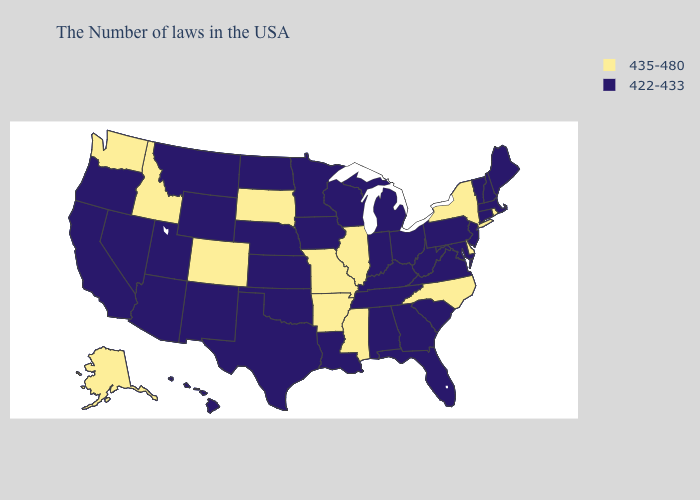Does the first symbol in the legend represent the smallest category?
Short answer required. No. Does Indiana have the same value as Washington?
Short answer required. No. Among the states that border Nebraska , does Colorado have the highest value?
Answer briefly. Yes. What is the lowest value in the MidWest?
Quick response, please. 422-433. Among the states that border Massachusetts , which have the highest value?
Short answer required. Rhode Island, New York. Name the states that have a value in the range 422-433?
Short answer required. Maine, Massachusetts, New Hampshire, Vermont, Connecticut, New Jersey, Maryland, Pennsylvania, Virginia, South Carolina, West Virginia, Ohio, Florida, Georgia, Michigan, Kentucky, Indiana, Alabama, Tennessee, Wisconsin, Louisiana, Minnesota, Iowa, Kansas, Nebraska, Oklahoma, Texas, North Dakota, Wyoming, New Mexico, Utah, Montana, Arizona, Nevada, California, Oregon, Hawaii. Among the states that border Pennsylvania , does Delaware have the lowest value?
Short answer required. No. What is the lowest value in the Northeast?
Give a very brief answer. 422-433. What is the value of Maryland?
Short answer required. 422-433. Name the states that have a value in the range 435-480?
Be succinct. Rhode Island, New York, Delaware, North Carolina, Illinois, Mississippi, Missouri, Arkansas, South Dakota, Colorado, Idaho, Washington, Alaska. Name the states that have a value in the range 422-433?
Write a very short answer. Maine, Massachusetts, New Hampshire, Vermont, Connecticut, New Jersey, Maryland, Pennsylvania, Virginia, South Carolina, West Virginia, Ohio, Florida, Georgia, Michigan, Kentucky, Indiana, Alabama, Tennessee, Wisconsin, Louisiana, Minnesota, Iowa, Kansas, Nebraska, Oklahoma, Texas, North Dakota, Wyoming, New Mexico, Utah, Montana, Arizona, Nevada, California, Oregon, Hawaii. What is the highest value in the USA?
Answer briefly. 435-480. What is the highest value in the USA?
Give a very brief answer. 435-480. Does Nevada have a higher value than Maine?
Give a very brief answer. No. What is the lowest value in the USA?
Write a very short answer. 422-433. 